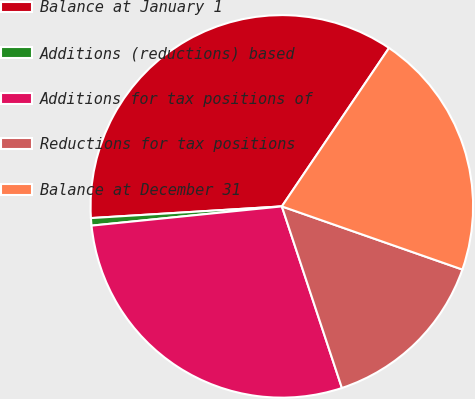Convert chart to OTSL. <chart><loc_0><loc_0><loc_500><loc_500><pie_chart><fcel>Balance at January 1<fcel>Additions (reductions) based<fcel>Additions for tax positions of<fcel>Reductions for tax positions<fcel>Balance at December 31<nl><fcel>35.44%<fcel>0.63%<fcel>28.48%<fcel>14.56%<fcel>20.89%<nl></chart> 